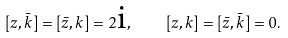<formula> <loc_0><loc_0><loc_500><loc_500>[ z , \bar { k } ] = [ \bar { z } , k ] = 2 \text {i} , \quad [ z , k ] = [ \bar { z } , \bar { k } ] = 0 .</formula> 